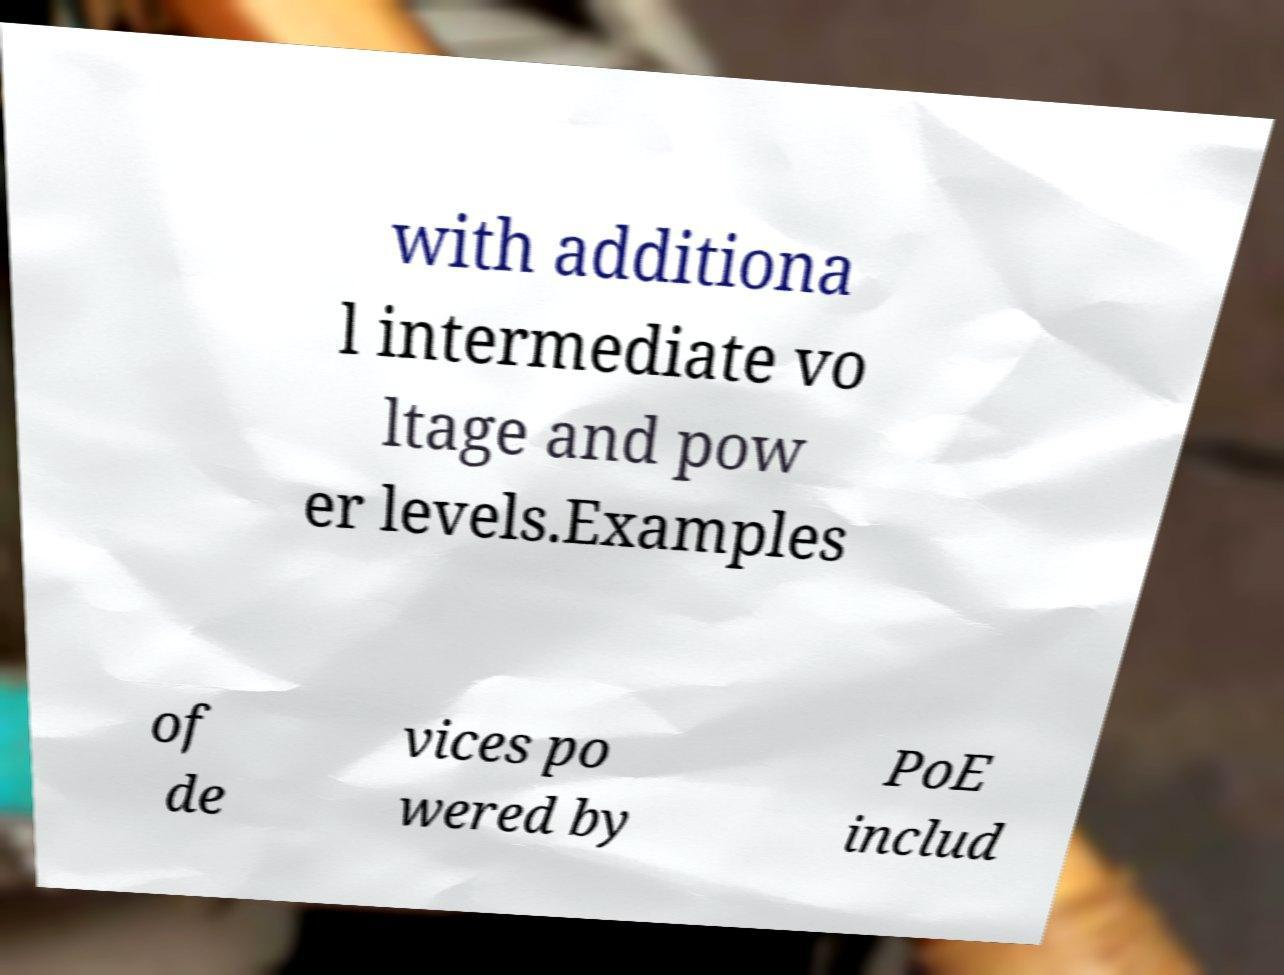I need the written content from this picture converted into text. Can you do that? with additiona l intermediate vo ltage and pow er levels.Examples of de vices po wered by PoE includ 